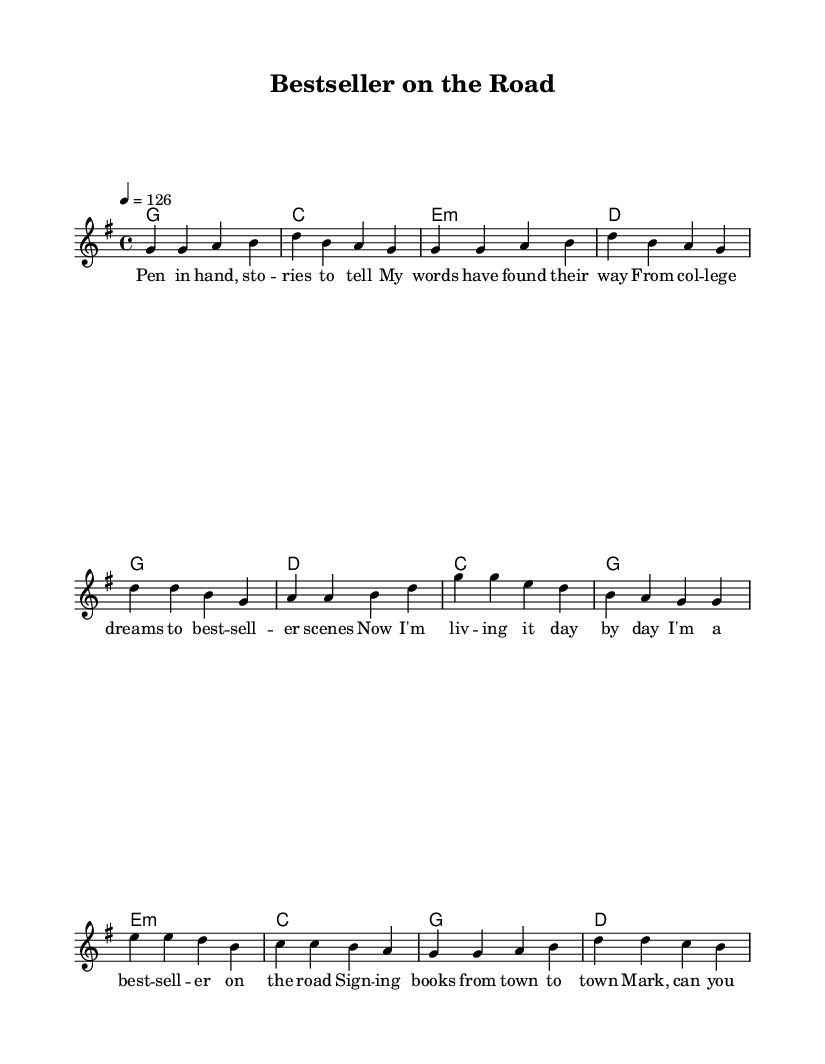What is the key signature of this music? The key signature is G major, indicated by one sharp (F#). This is determined by the 'g' marking at the beginning of the global section, which specifies the key.
Answer: G major What is the time signature of this music? The time signature is 4/4, shown at the start of the global section as "4/4". This indicates that there are four beats in each measure, and the quarter note gets one beat.
Answer: 4/4 What is the tempo marking? The tempo marking is 126 beats per minute, indicated by "4 = 126" in the global section, which means that the quarter note will be played at this speed.
Answer: 126 How many measures are in the chorus? The chorus consists of four measures, which can be counted from the chords and melody sections dedicated to the chorus. Each phrase completes a measure.
Answer: 4 What is the first word of the lyrics? The first word of the lyrics is "Pen," which begins the lyrical section of the song. This can be found in the verseWords section, clearly written out.
Answer: Pen Is there a bridge in this song? Yes, there is a bridge, indicated by the distinct melody and harmony pattern that appears after the chorus. This section varies from the verse and chorus structure.
Answer: Yes 